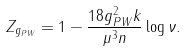Convert formula to latex. <formula><loc_0><loc_0><loc_500><loc_500>Z _ { g _ { P W } } = 1 - \frac { 1 8 g ^ { 2 } _ { P W } k } { \mu ^ { 3 } n } \log \nu .</formula> 